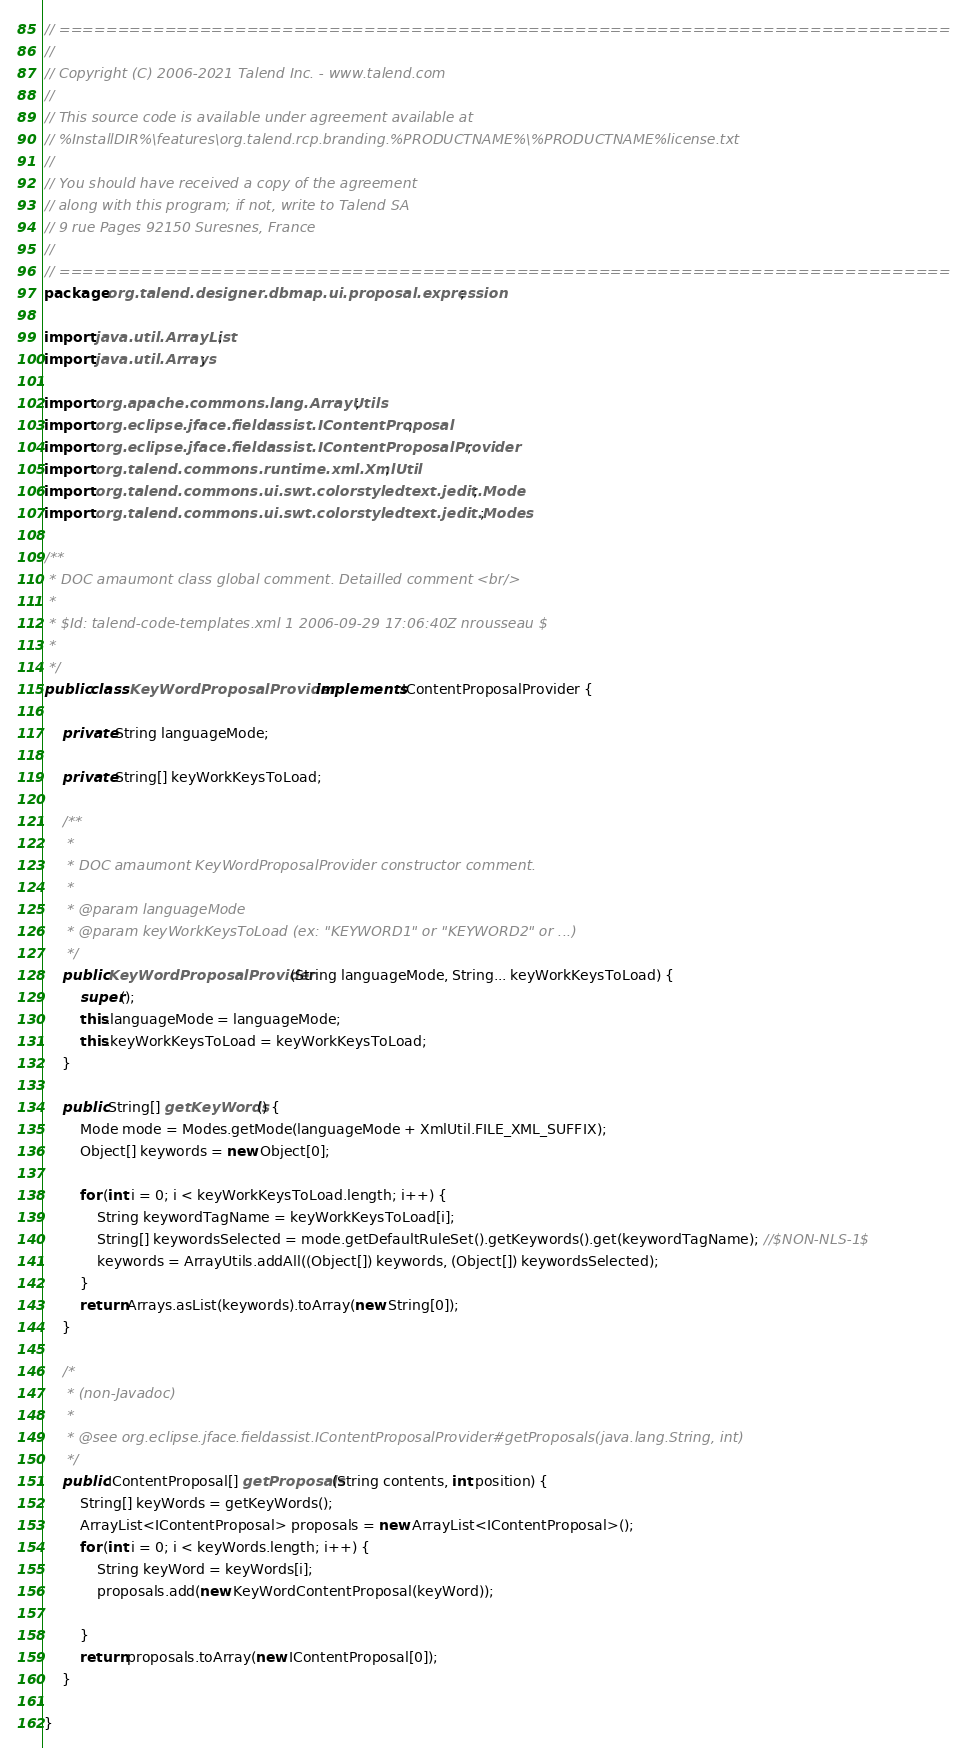Convert code to text. <code><loc_0><loc_0><loc_500><loc_500><_Java_>// ============================================================================
//
// Copyright (C) 2006-2021 Talend Inc. - www.talend.com
//
// This source code is available under agreement available at
// %InstallDIR%\features\org.talend.rcp.branding.%PRODUCTNAME%\%PRODUCTNAME%license.txt
//
// You should have received a copy of the agreement
// along with this program; if not, write to Talend SA
// 9 rue Pages 92150 Suresnes, France
//
// ============================================================================
package org.talend.designer.dbmap.ui.proposal.expression;

import java.util.ArrayList;
import java.util.Arrays;

import org.apache.commons.lang.ArrayUtils;
import org.eclipse.jface.fieldassist.IContentProposal;
import org.eclipse.jface.fieldassist.IContentProposalProvider;
import org.talend.commons.runtime.xml.XmlUtil;
import org.talend.commons.ui.swt.colorstyledtext.jedit.Mode;
import org.talend.commons.ui.swt.colorstyledtext.jedit.Modes;

/**
 * DOC amaumont class global comment. Detailled comment <br/>
 *
 * $Id: talend-code-templates.xml 1 2006-09-29 17:06:40Z nrousseau $
 *
 */
public class KeyWordProposalProvider implements IContentProposalProvider {

    private String languageMode;

    private String[] keyWorkKeysToLoad;

    /**
     *
     * DOC amaumont KeyWordProposalProvider constructor comment.
     *
     * @param languageMode
     * @param keyWorkKeysToLoad (ex: "KEYWORD1" or "KEYWORD2" or ...)
     */
    public KeyWordProposalProvider(String languageMode, String... keyWorkKeysToLoad) {
        super();
        this.languageMode = languageMode;
        this.keyWorkKeysToLoad = keyWorkKeysToLoad;
    }

    public String[] getKeyWords() {
        Mode mode = Modes.getMode(languageMode + XmlUtil.FILE_XML_SUFFIX);
        Object[] keywords = new Object[0];

        for (int i = 0; i < keyWorkKeysToLoad.length; i++) {
            String keywordTagName = keyWorkKeysToLoad[i];
            String[] keywordsSelected = mode.getDefaultRuleSet().getKeywords().get(keywordTagName); //$NON-NLS-1$
            keywords = ArrayUtils.addAll((Object[]) keywords, (Object[]) keywordsSelected);
        }
        return Arrays.asList(keywords).toArray(new String[0]);
    }

    /*
     * (non-Javadoc)
     *
     * @see org.eclipse.jface.fieldassist.IContentProposalProvider#getProposals(java.lang.String, int)
     */
    public IContentProposal[] getProposals(String contents, int position) {
        String[] keyWords = getKeyWords();
        ArrayList<IContentProposal> proposals = new ArrayList<IContentProposal>();
        for (int i = 0; i < keyWords.length; i++) {
            String keyWord = keyWords[i];
            proposals.add(new KeyWordContentProposal(keyWord));

        }
        return proposals.toArray(new IContentProposal[0]);
    }

}
</code> 